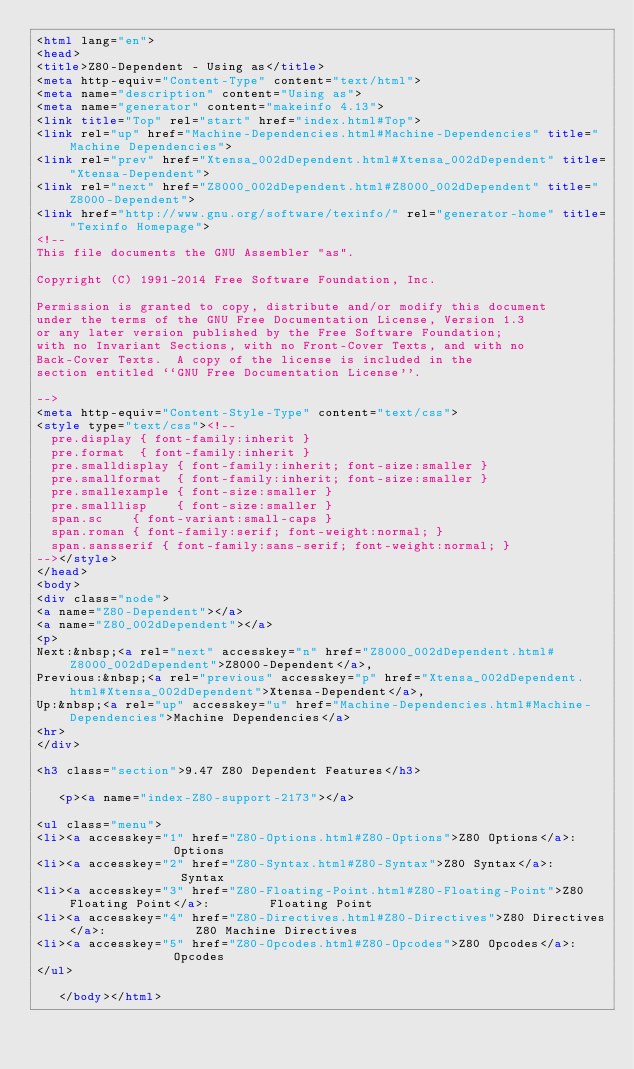Convert code to text. <code><loc_0><loc_0><loc_500><loc_500><_HTML_><html lang="en">
<head>
<title>Z80-Dependent - Using as</title>
<meta http-equiv="Content-Type" content="text/html">
<meta name="description" content="Using as">
<meta name="generator" content="makeinfo 4.13">
<link title="Top" rel="start" href="index.html#Top">
<link rel="up" href="Machine-Dependencies.html#Machine-Dependencies" title="Machine Dependencies">
<link rel="prev" href="Xtensa_002dDependent.html#Xtensa_002dDependent" title="Xtensa-Dependent">
<link rel="next" href="Z8000_002dDependent.html#Z8000_002dDependent" title="Z8000-Dependent">
<link href="http://www.gnu.org/software/texinfo/" rel="generator-home" title="Texinfo Homepage">
<!--
This file documents the GNU Assembler "as".

Copyright (C) 1991-2014 Free Software Foundation, Inc.

Permission is granted to copy, distribute and/or modify this document
under the terms of the GNU Free Documentation License, Version 1.3
or any later version published by the Free Software Foundation;
with no Invariant Sections, with no Front-Cover Texts, and with no
Back-Cover Texts.  A copy of the license is included in the
section entitled ``GNU Free Documentation License''.

-->
<meta http-equiv="Content-Style-Type" content="text/css">
<style type="text/css"><!--
  pre.display { font-family:inherit }
  pre.format  { font-family:inherit }
  pre.smalldisplay { font-family:inherit; font-size:smaller }
  pre.smallformat  { font-family:inherit; font-size:smaller }
  pre.smallexample { font-size:smaller }
  pre.smalllisp    { font-size:smaller }
  span.sc    { font-variant:small-caps }
  span.roman { font-family:serif; font-weight:normal; } 
  span.sansserif { font-family:sans-serif; font-weight:normal; } 
--></style>
</head>
<body>
<div class="node">
<a name="Z80-Dependent"></a>
<a name="Z80_002dDependent"></a>
<p>
Next:&nbsp;<a rel="next" accesskey="n" href="Z8000_002dDependent.html#Z8000_002dDependent">Z8000-Dependent</a>,
Previous:&nbsp;<a rel="previous" accesskey="p" href="Xtensa_002dDependent.html#Xtensa_002dDependent">Xtensa-Dependent</a>,
Up:&nbsp;<a rel="up" accesskey="u" href="Machine-Dependencies.html#Machine-Dependencies">Machine Dependencies</a>
<hr>
</div>

<h3 class="section">9.47 Z80 Dependent Features</h3>

   <p><a name="index-Z80-support-2173"></a>

<ul class="menu">
<li><a accesskey="1" href="Z80-Options.html#Z80-Options">Z80 Options</a>:               Options
<li><a accesskey="2" href="Z80-Syntax.html#Z80-Syntax">Z80 Syntax</a>:                Syntax
<li><a accesskey="3" href="Z80-Floating-Point.html#Z80-Floating-Point">Z80 Floating Point</a>:        Floating Point
<li><a accesskey="4" href="Z80-Directives.html#Z80-Directives">Z80 Directives</a>:            Z80 Machine Directives
<li><a accesskey="5" href="Z80-Opcodes.html#Z80-Opcodes">Z80 Opcodes</a>:               Opcodes
</ul>

   </body></html>

</code> 